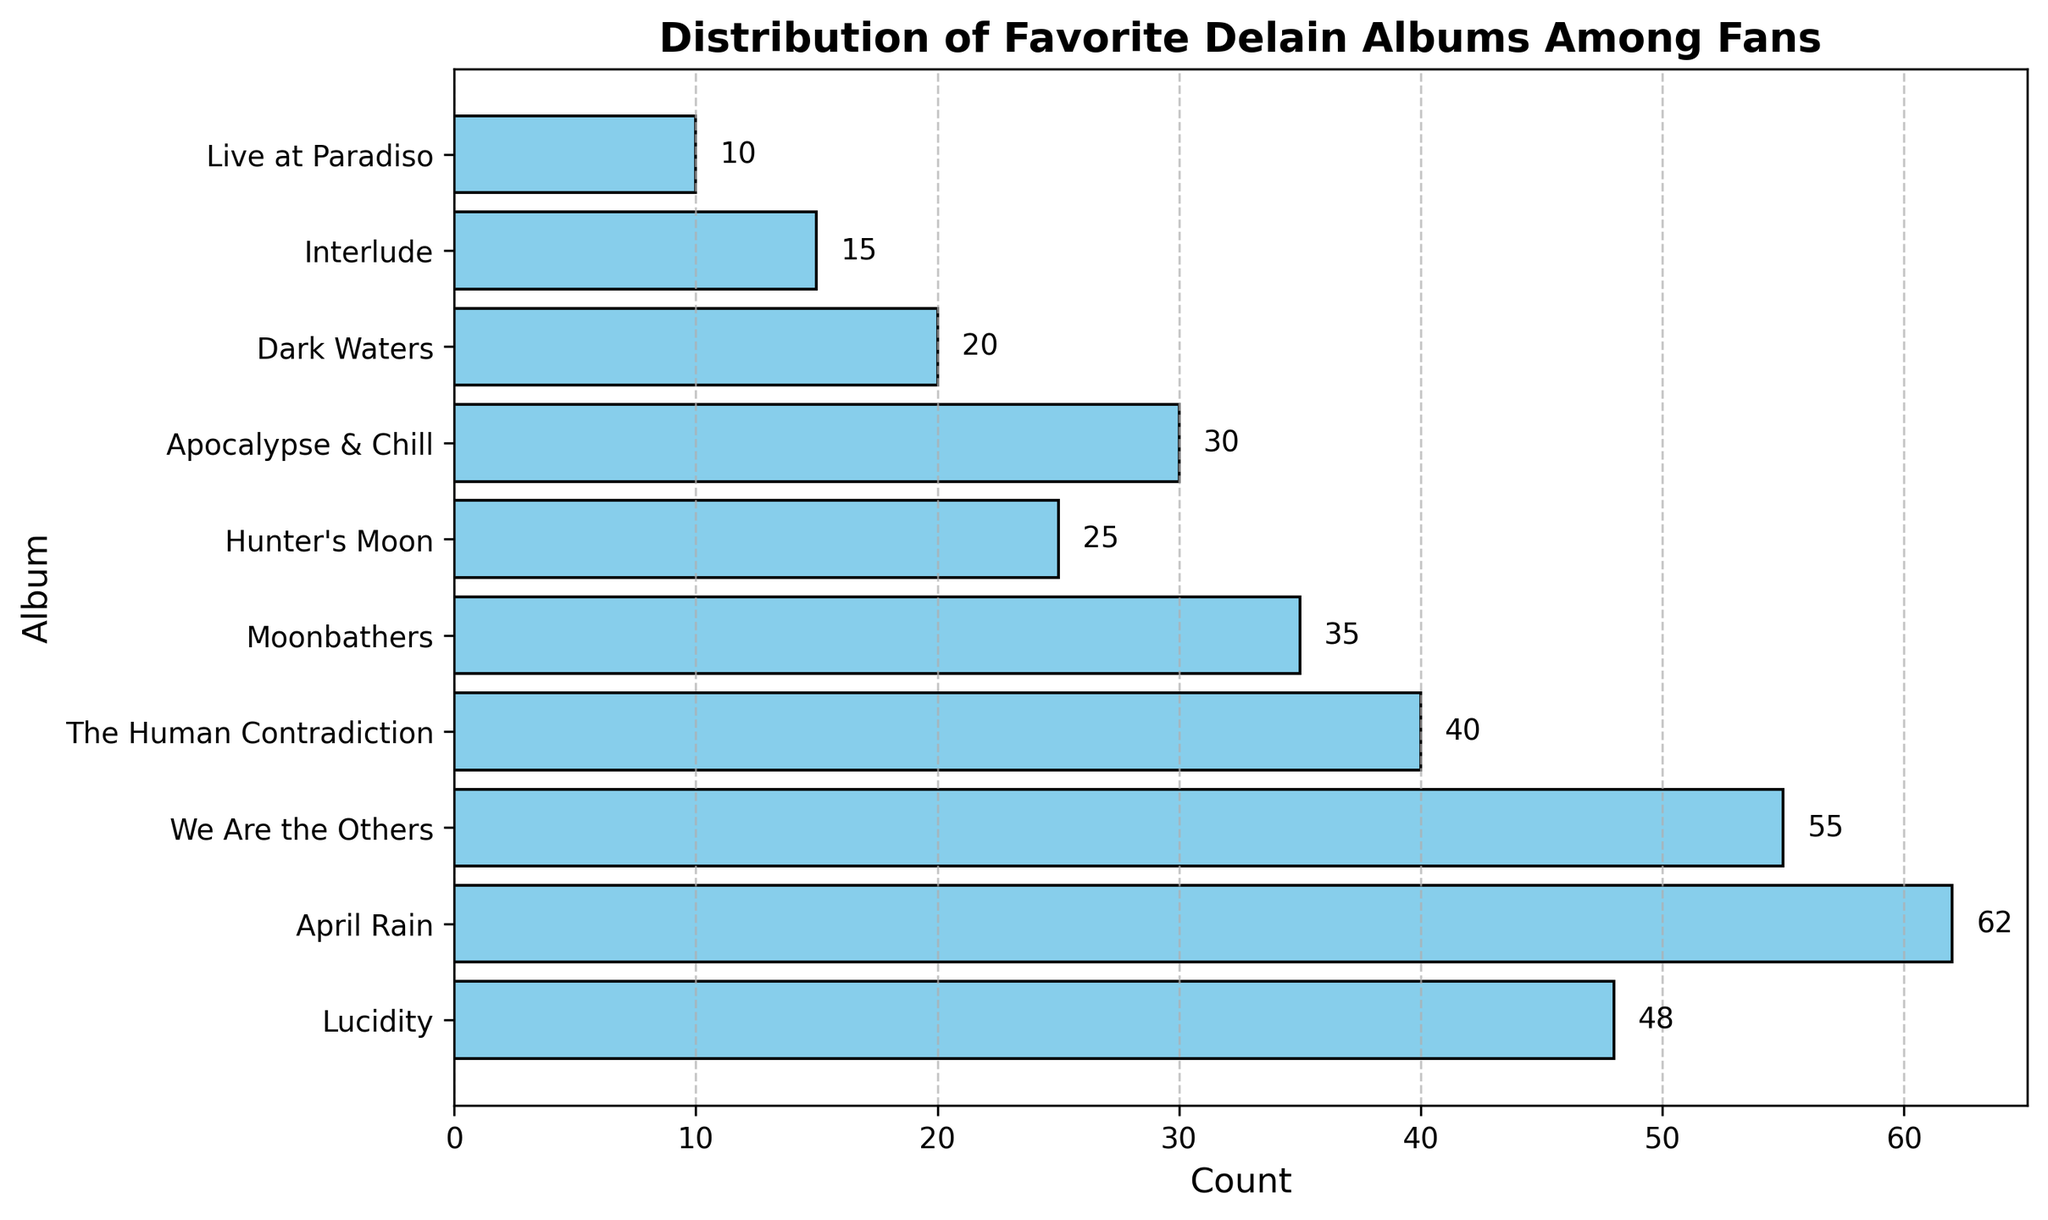What's the most favorite Delain album according to the fans? The bar with the longest length indicates the most favorite album. "April Rain" has the highest count with 62.
Answer: April Rain How many more fans prefer "April Rain" over "We Are the Others"? Subtract the count of "We Are the Others" (55) from the count of "April Rain" (62). 62 - 55 = 7 fans.
Answer: 7 fans Which album has the least number of fans and how many fans is that? The bar with the shortest length represents the least preferred album. "Live at Paradiso" has the shortest bar with 10 fans.
Answer: Live at Paradiso, 10 fans What is the total number of fans who prefer "Lucidity" and "Moonbathers"? Add the counts for both albums. "Lucidity" has 48 fans and "Moonbathers" has 35. 48 + 35 = 83 fans.
Answer: 83 fans Compare the preference of "Apocalypse & Chill" to "The Human Contradiction". Which album is preferred more and by how many fans? Subtract the count of "The Human Contradiction" (40) from "Apocalypse & Chill" (30). 40 - 30 = 10 fans. "The Human Contradiction" is preferred by 10 more fans.
Answer: The Human Contradiction, 10 fans What is the median value of fans' count for these albums? Order the albums by their count: [10, 15, 20, 25, 30, 35, 40, 48, 55, 62]. Since there are 10 values, the median is the average of the 5th and 6th values. (30 + 35) / 2 = 32.5.
Answer: 32.5 Which albums have more than 50 fans but less than 60 fans? Look for the bars with counts between 50 and 60. "We Are the Others" with 55 fans falls into this range.
Answer: We Are the Others What is the combined count of fans for "Hunter's Moon" and "Dark Waters"? Add the counts for both albums. "Hunter's Moon" has 25 fans and "Dark Waters" has 20. 25 + 20 = 45 fans.
Answer: 45 fans How many albums have a count of 30 or more fans? Count the bars with values equal or greater than 30. Here, there are 6 albums: "Lucidity," "April Rain," "We Are the Others," "The Human Contradiction," "Moonbathers," "Apocalypse & Chill."
Answer: 6 albums Which albums have exactly 40 fans? Identify the bar with a count of exactly 40. This corresponds to "The Human Contradiction."
Answer: The Human Contradiction 